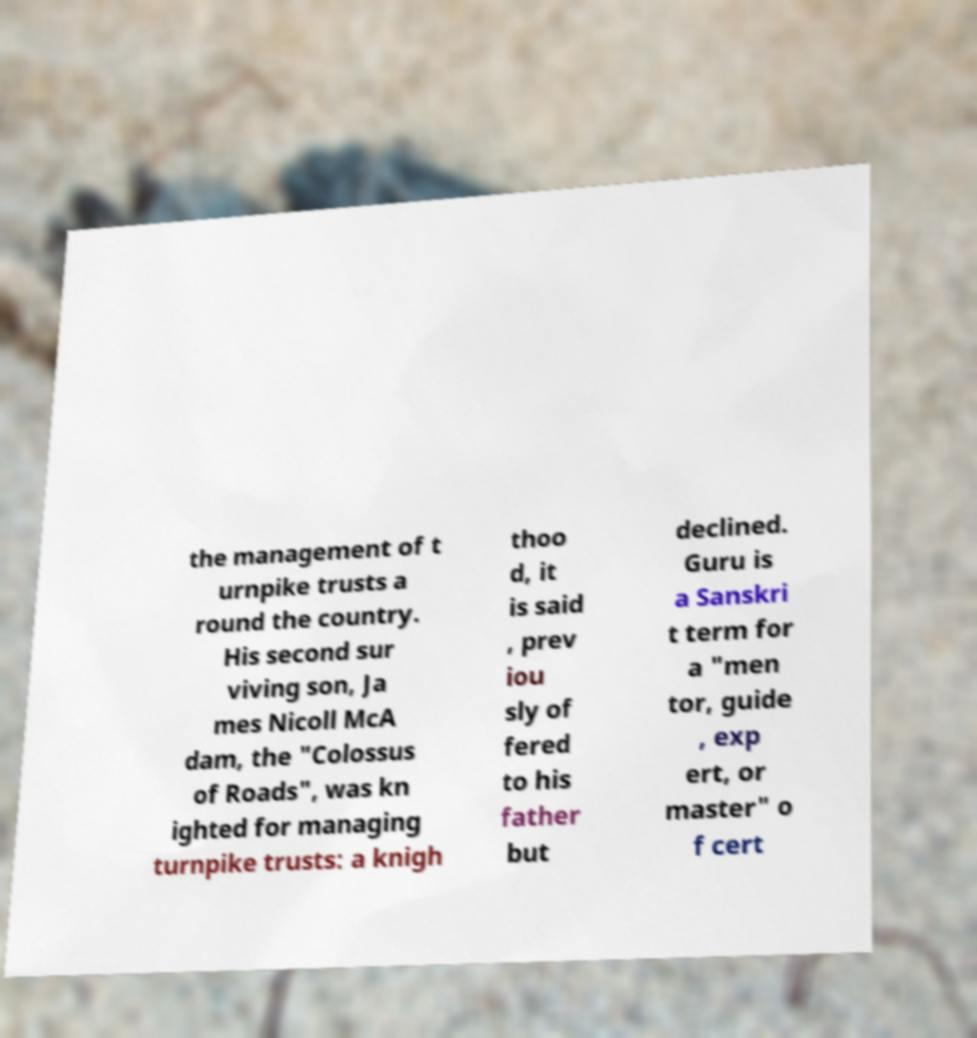What messages or text are displayed in this image? I need them in a readable, typed format. the management of t urnpike trusts a round the country. His second sur viving son, Ja mes Nicoll McA dam, the "Colossus of Roads", was kn ighted for managing turnpike trusts: a knigh thoo d, it is said , prev iou sly of fered to his father but declined. Guru is a Sanskri t term for a "men tor, guide , exp ert, or master" o f cert 